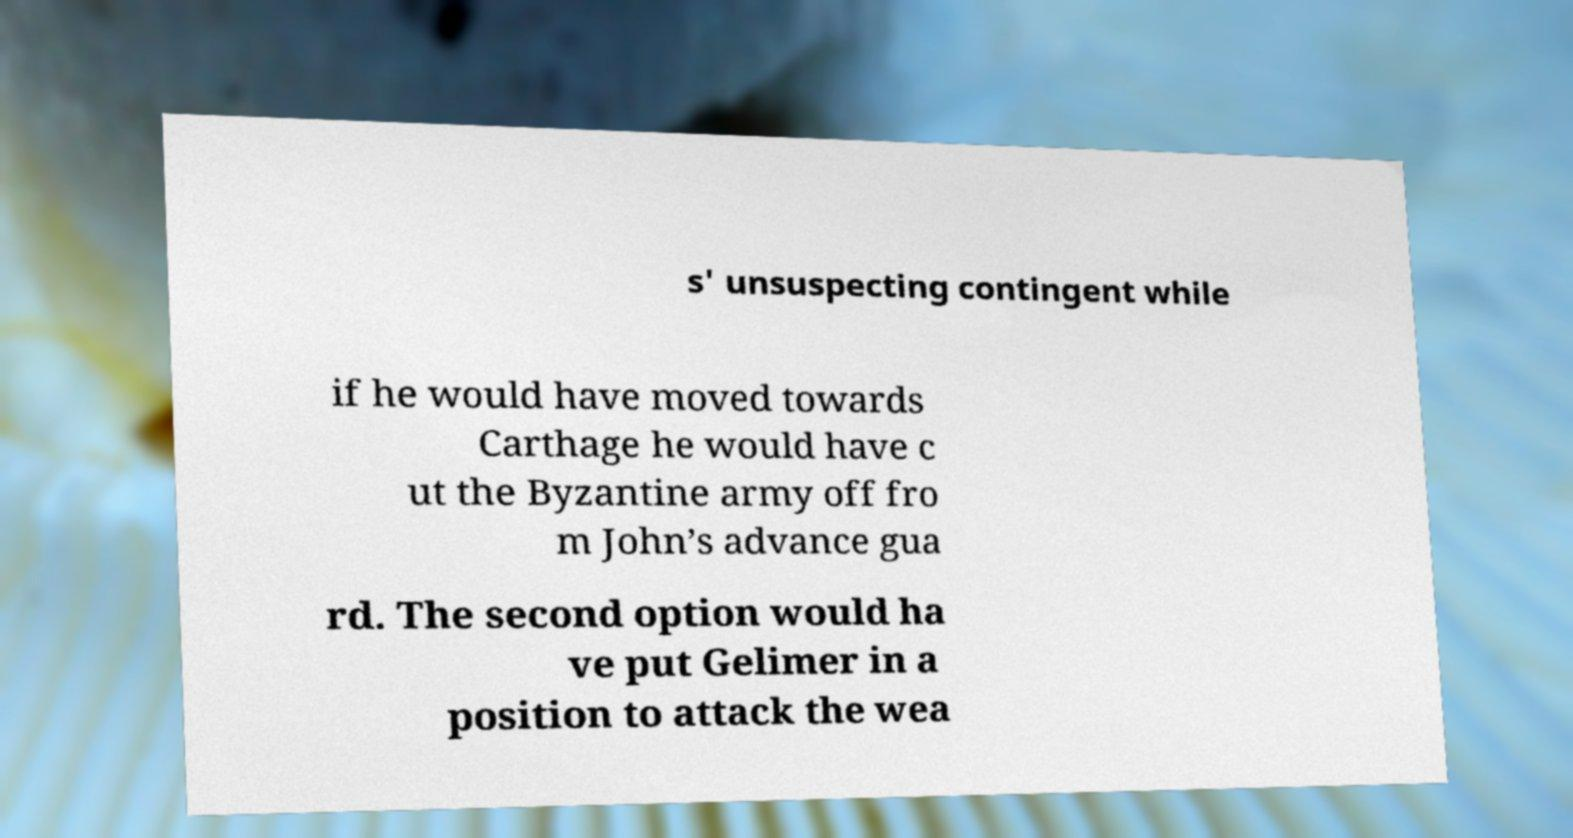What messages or text are displayed in this image? I need them in a readable, typed format. s' unsuspecting contingent while if he would have moved towards Carthage he would have c ut the Byzantine army off fro m John’s advance gua rd. The second option would ha ve put Gelimer in a position to attack the wea 